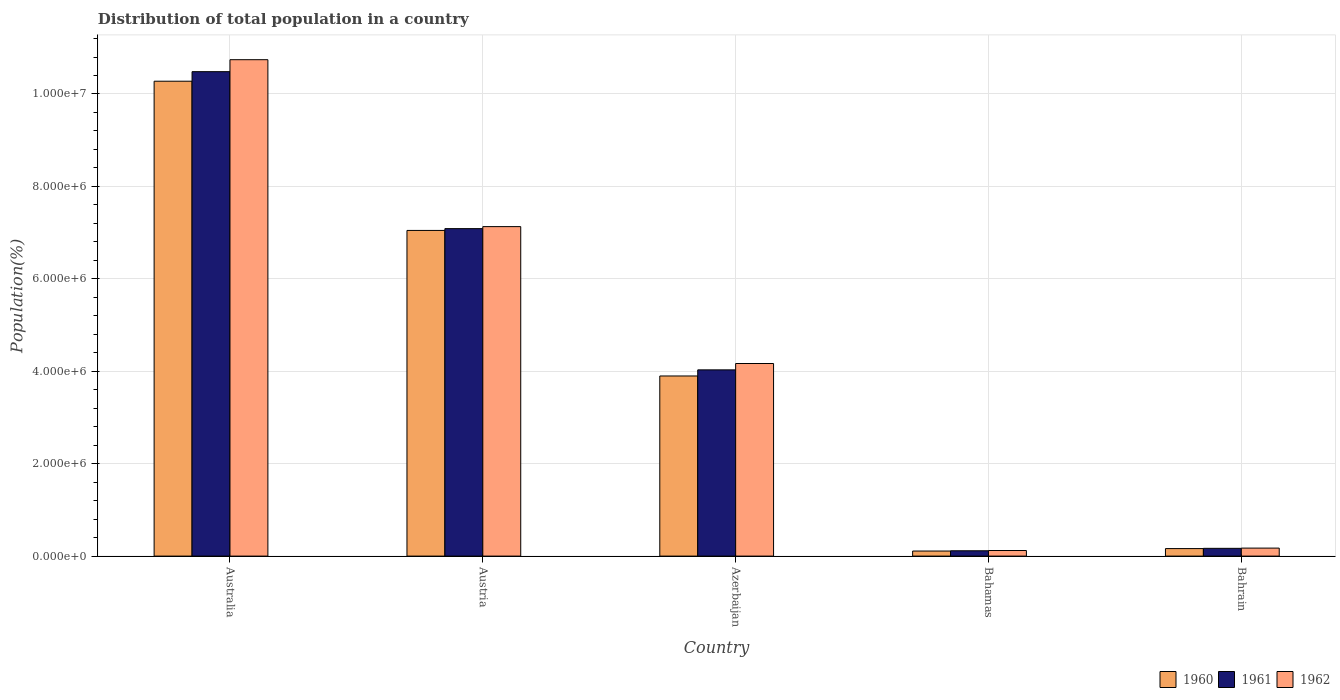How many groups of bars are there?
Make the answer very short. 5. Are the number of bars per tick equal to the number of legend labels?
Offer a terse response. Yes. How many bars are there on the 5th tick from the left?
Make the answer very short. 3. How many bars are there on the 4th tick from the right?
Offer a very short reply. 3. What is the label of the 3rd group of bars from the left?
Offer a very short reply. Azerbaijan. What is the population of in 1961 in Austria?
Your response must be concise. 7.09e+06. Across all countries, what is the maximum population of in 1962?
Your answer should be very brief. 1.07e+07. Across all countries, what is the minimum population of in 1960?
Give a very brief answer. 1.10e+05. In which country was the population of in 1960 maximum?
Give a very brief answer. Australia. In which country was the population of in 1960 minimum?
Offer a terse response. Bahamas. What is the total population of in 1962 in the graph?
Your answer should be very brief. 2.23e+07. What is the difference between the population of in 1961 in Bahamas and that in Bahrain?
Keep it short and to the point. -5.28e+04. What is the difference between the population of in 1960 in Bahrain and the population of in 1962 in Azerbaijan?
Your answer should be compact. -4.01e+06. What is the average population of in 1962 per country?
Ensure brevity in your answer.  4.47e+06. What is the difference between the population of of/in 1961 and population of of/in 1962 in Bahamas?
Your answer should be very brief. -5975. What is the ratio of the population of in 1961 in Australia to that in Azerbaijan?
Give a very brief answer. 2.6. Is the difference between the population of in 1961 in Azerbaijan and Bahrain greater than the difference between the population of in 1962 in Azerbaijan and Bahrain?
Give a very brief answer. No. What is the difference between the highest and the second highest population of in 1962?
Your response must be concise. 3.61e+06. What is the difference between the highest and the lowest population of in 1960?
Ensure brevity in your answer.  1.02e+07. Is the sum of the population of in 1960 in Austria and Azerbaijan greater than the maximum population of in 1961 across all countries?
Give a very brief answer. Yes. What does the 1st bar from the right in Bahrain represents?
Your answer should be very brief. 1962. Is it the case that in every country, the sum of the population of in 1961 and population of in 1960 is greater than the population of in 1962?
Give a very brief answer. Yes. Are all the bars in the graph horizontal?
Make the answer very short. No. How many countries are there in the graph?
Offer a terse response. 5. What is the difference between two consecutive major ticks on the Y-axis?
Offer a very short reply. 2.00e+06. Are the values on the major ticks of Y-axis written in scientific E-notation?
Provide a short and direct response. Yes. Does the graph contain any zero values?
Ensure brevity in your answer.  No. What is the title of the graph?
Provide a short and direct response. Distribution of total population in a country. What is the label or title of the X-axis?
Keep it short and to the point. Country. What is the label or title of the Y-axis?
Offer a terse response. Population(%). What is the Population(%) of 1960 in Australia?
Keep it short and to the point. 1.03e+07. What is the Population(%) of 1961 in Australia?
Make the answer very short. 1.05e+07. What is the Population(%) of 1962 in Australia?
Keep it short and to the point. 1.07e+07. What is the Population(%) in 1960 in Austria?
Your answer should be compact. 7.05e+06. What is the Population(%) of 1961 in Austria?
Provide a short and direct response. 7.09e+06. What is the Population(%) of 1962 in Austria?
Provide a short and direct response. 7.13e+06. What is the Population(%) in 1960 in Azerbaijan?
Your answer should be very brief. 3.90e+06. What is the Population(%) in 1961 in Azerbaijan?
Provide a short and direct response. 4.03e+06. What is the Population(%) in 1962 in Azerbaijan?
Give a very brief answer. 4.17e+06. What is the Population(%) of 1960 in Bahamas?
Give a very brief answer. 1.10e+05. What is the Population(%) of 1961 in Bahamas?
Ensure brevity in your answer.  1.15e+05. What is the Population(%) in 1962 in Bahamas?
Give a very brief answer. 1.21e+05. What is the Population(%) of 1960 in Bahrain?
Give a very brief answer. 1.63e+05. What is the Population(%) of 1961 in Bahrain?
Offer a terse response. 1.68e+05. What is the Population(%) in 1962 in Bahrain?
Give a very brief answer. 1.73e+05. Across all countries, what is the maximum Population(%) in 1960?
Provide a succinct answer. 1.03e+07. Across all countries, what is the maximum Population(%) in 1961?
Ensure brevity in your answer.  1.05e+07. Across all countries, what is the maximum Population(%) of 1962?
Your answer should be very brief. 1.07e+07. Across all countries, what is the minimum Population(%) of 1960?
Provide a succinct answer. 1.10e+05. Across all countries, what is the minimum Population(%) of 1961?
Ensure brevity in your answer.  1.15e+05. Across all countries, what is the minimum Population(%) of 1962?
Ensure brevity in your answer.  1.21e+05. What is the total Population(%) in 1960 in the graph?
Give a very brief answer. 2.15e+07. What is the total Population(%) in 1961 in the graph?
Give a very brief answer. 2.19e+07. What is the total Population(%) in 1962 in the graph?
Make the answer very short. 2.23e+07. What is the difference between the Population(%) of 1960 in Australia and that in Austria?
Provide a succinct answer. 3.23e+06. What is the difference between the Population(%) in 1961 in Australia and that in Austria?
Make the answer very short. 3.40e+06. What is the difference between the Population(%) of 1962 in Australia and that in Austria?
Provide a short and direct response. 3.61e+06. What is the difference between the Population(%) in 1960 in Australia and that in Azerbaijan?
Make the answer very short. 6.38e+06. What is the difference between the Population(%) of 1961 in Australia and that in Azerbaijan?
Offer a very short reply. 6.45e+06. What is the difference between the Population(%) in 1962 in Australia and that in Azerbaijan?
Offer a very short reply. 6.57e+06. What is the difference between the Population(%) in 1960 in Australia and that in Bahamas?
Provide a succinct answer. 1.02e+07. What is the difference between the Population(%) in 1961 in Australia and that in Bahamas?
Your response must be concise. 1.04e+07. What is the difference between the Population(%) in 1962 in Australia and that in Bahamas?
Offer a very short reply. 1.06e+07. What is the difference between the Population(%) in 1960 in Australia and that in Bahrain?
Your answer should be very brief. 1.01e+07. What is the difference between the Population(%) of 1961 in Australia and that in Bahrain?
Ensure brevity in your answer.  1.03e+07. What is the difference between the Population(%) of 1962 in Australia and that in Bahrain?
Ensure brevity in your answer.  1.06e+07. What is the difference between the Population(%) in 1960 in Austria and that in Azerbaijan?
Ensure brevity in your answer.  3.15e+06. What is the difference between the Population(%) in 1961 in Austria and that in Azerbaijan?
Offer a terse response. 3.06e+06. What is the difference between the Population(%) of 1962 in Austria and that in Azerbaijan?
Ensure brevity in your answer.  2.96e+06. What is the difference between the Population(%) in 1960 in Austria and that in Bahamas?
Provide a short and direct response. 6.94e+06. What is the difference between the Population(%) of 1961 in Austria and that in Bahamas?
Ensure brevity in your answer.  6.97e+06. What is the difference between the Population(%) of 1962 in Austria and that in Bahamas?
Provide a succinct answer. 7.01e+06. What is the difference between the Population(%) of 1960 in Austria and that in Bahrain?
Provide a short and direct response. 6.89e+06. What is the difference between the Population(%) of 1961 in Austria and that in Bahrain?
Your answer should be very brief. 6.92e+06. What is the difference between the Population(%) in 1962 in Austria and that in Bahrain?
Ensure brevity in your answer.  6.96e+06. What is the difference between the Population(%) of 1960 in Azerbaijan and that in Bahamas?
Your response must be concise. 3.79e+06. What is the difference between the Population(%) in 1961 in Azerbaijan and that in Bahamas?
Your answer should be very brief. 3.92e+06. What is the difference between the Population(%) of 1962 in Azerbaijan and that in Bahamas?
Provide a succinct answer. 4.05e+06. What is the difference between the Population(%) in 1960 in Azerbaijan and that in Bahrain?
Provide a short and direct response. 3.74e+06. What is the difference between the Population(%) in 1961 in Azerbaijan and that in Bahrain?
Your response must be concise. 3.86e+06. What is the difference between the Population(%) in 1962 in Azerbaijan and that in Bahrain?
Your answer should be compact. 3.99e+06. What is the difference between the Population(%) in 1960 in Bahamas and that in Bahrain?
Provide a succinct answer. -5.30e+04. What is the difference between the Population(%) of 1961 in Bahamas and that in Bahrain?
Keep it short and to the point. -5.28e+04. What is the difference between the Population(%) of 1962 in Bahamas and that in Bahrain?
Ensure brevity in your answer.  -5.20e+04. What is the difference between the Population(%) in 1960 in Australia and the Population(%) in 1961 in Austria?
Ensure brevity in your answer.  3.19e+06. What is the difference between the Population(%) in 1960 in Australia and the Population(%) in 1962 in Austria?
Provide a succinct answer. 3.15e+06. What is the difference between the Population(%) of 1961 in Australia and the Population(%) of 1962 in Austria?
Your answer should be compact. 3.35e+06. What is the difference between the Population(%) in 1960 in Australia and the Population(%) in 1961 in Azerbaijan?
Offer a very short reply. 6.25e+06. What is the difference between the Population(%) in 1960 in Australia and the Population(%) in 1962 in Azerbaijan?
Offer a terse response. 6.11e+06. What is the difference between the Population(%) in 1961 in Australia and the Population(%) in 1962 in Azerbaijan?
Offer a very short reply. 6.32e+06. What is the difference between the Population(%) in 1960 in Australia and the Population(%) in 1961 in Bahamas?
Your response must be concise. 1.02e+07. What is the difference between the Population(%) in 1960 in Australia and the Population(%) in 1962 in Bahamas?
Provide a short and direct response. 1.02e+07. What is the difference between the Population(%) of 1961 in Australia and the Population(%) of 1962 in Bahamas?
Ensure brevity in your answer.  1.04e+07. What is the difference between the Population(%) of 1960 in Australia and the Population(%) of 1961 in Bahrain?
Give a very brief answer. 1.01e+07. What is the difference between the Population(%) of 1960 in Australia and the Population(%) of 1962 in Bahrain?
Make the answer very short. 1.01e+07. What is the difference between the Population(%) in 1961 in Australia and the Population(%) in 1962 in Bahrain?
Offer a very short reply. 1.03e+07. What is the difference between the Population(%) of 1960 in Austria and the Population(%) of 1961 in Azerbaijan?
Make the answer very short. 3.02e+06. What is the difference between the Population(%) of 1960 in Austria and the Population(%) of 1962 in Azerbaijan?
Make the answer very short. 2.88e+06. What is the difference between the Population(%) of 1961 in Austria and the Population(%) of 1962 in Azerbaijan?
Offer a terse response. 2.92e+06. What is the difference between the Population(%) in 1960 in Austria and the Population(%) in 1961 in Bahamas?
Make the answer very short. 6.93e+06. What is the difference between the Population(%) in 1960 in Austria and the Population(%) in 1962 in Bahamas?
Your answer should be very brief. 6.93e+06. What is the difference between the Population(%) in 1961 in Austria and the Population(%) in 1962 in Bahamas?
Provide a succinct answer. 6.97e+06. What is the difference between the Population(%) of 1960 in Austria and the Population(%) of 1961 in Bahrain?
Provide a succinct answer. 6.88e+06. What is the difference between the Population(%) in 1960 in Austria and the Population(%) in 1962 in Bahrain?
Your answer should be very brief. 6.87e+06. What is the difference between the Population(%) of 1961 in Austria and the Population(%) of 1962 in Bahrain?
Keep it short and to the point. 6.91e+06. What is the difference between the Population(%) of 1960 in Azerbaijan and the Population(%) of 1961 in Bahamas?
Ensure brevity in your answer.  3.78e+06. What is the difference between the Population(%) in 1960 in Azerbaijan and the Population(%) in 1962 in Bahamas?
Your answer should be very brief. 3.78e+06. What is the difference between the Population(%) in 1961 in Azerbaijan and the Population(%) in 1962 in Bahamas?
Offer a very short reply. 3.91e+06. What is the difference between the Population(%) in 1960 in Azerbaijan and the Population(%) in 1961 in Bahrain?
Your answer should be compact. 3.73e+06. What is the difference between the Population(%) of 1960 in Azerbaijan and the Population(%) of 1962 in Bahrain?
Ensure brevity in your answer.  3.72e+06. What is the difference between the Population(%) in 1961 in Azerbaijan and the Population(%) in 1962 in Bahrain?
Your answer should be compact. 3.86e+06. What is the difference between the Population(%) of 1960 in Bahamas and the Population(%) of 1961 in Bahrain?
Provide a short and direct response. -5.84e+04. What is the difference between the Population(%) in 1960 in Bahamas and the Population(%) in 1962 in Bahrain?
Ensure brevity in your answer.  -6.36e+04. What is the difference between the Population(%) in 1961 in Bahamas and the Population(%) in 1962 in Bahrain?
Ensure brevity in your answer.  -5.80e+04. What is the average Population(%) in 1960 per country?
Your answer should be compact. 4.30e+06. What is the average Population(%) in 1961 per country?
Offer a very short reply. 4.38e+06. What is the average Population(%) in 1962 per country?
Give a very brief answer. 4.47e+06. What is the difference between the Population(%) in 1960 and Population(%) in 1961 in Australia?
Give a very brief answer. -2.07e+05. What is the difference between the Population(%) in 1960 and Population(%) in 1962 in Australia?
Offer a terse response. -4.66e+05. What is the difference between the Population(%) in 1961 and Population(%) in 1962 in Australia?
Make the answer very short. -2.59e+05. What is the difference between the Population(%) in 1960 and Population(%) in 1961 in Austria?
Your response must be concise. -3.88e+04. What is the difference between the Population(%) in 1960 and Population(%) in 1962 in Austria?
Provide a short and direct response. -8.23e+04. What is the difference between the Population(%) of 1961 and Population(%) of 1962 in Austria?
Your answer should be very brief. -4.36e+04. What is the difference between the Population(%) in 1960 and Population(%) in 1961 in Azerbaijan?
Give a very brief answer. -1.32e+05. What is the difference between the Population(%) of 1960 and Population(%) of 1962 in Azerbaijan?
Ensure brevity in your answer.  -2.70e+05. What is the difference between the Population(%) of 1961 and Population(%) of 1962 in Azerbaijan?
Your response must be concise. -1.37e+05. What is the difference between the Population(%) of 1960 and Population(%) of 1961 in Bahamas?
Give a very brief answer. -5582. What is the difference between the Population(%) of 1960 and Population(%) of 1962 in Bahamas?
Make the answer very short. -1.16e+04. What is the difference between the Population(%) of 1961 and Population(%) of 1962 in Bahamas?
Your answer should be compact. -5975. What is the difference between the Population(%) in 1960 and Population(%) in 1961 in Bahrain?
Offer a very short reply. -5423. What is the difference between the Population(%) in 1960 and Population(%) in 1962 in Bahrain?
Your answer should be compact. -1.06e+04. What is the difference between the Population(%) in 1961 and Population(%) in 1962 in Bahrain?
Provide a short and direct response. -5183. What is the ratio of the Population(%) in 1960 in Australia to that in Austria?
Offer a very short reply. 1.46. What is the ratio of the Population(%) in 1961 in Australia to that in Austria?
Your answer should be very brief. 1.48. What is the ratio of the Population(%) in 1962 in Australia to that in Austria?
Offer a very short reply. 1.51. What is the ratio of the Population(%) in 1960 in Australia to that in Azerbaijan?
Offer a very short reply. 2.64. What is the ratio of the Population(%) of 1961 in Australia to that in Azerbaijan?
Your response must be concise. 2.6. What is the ratio of the Population(%) of 1962 in Australia to that in Azerbaijan?
Provide a succinct answer. 2.58. What is the ratio of the Population(%) of 1960 in Australia to that in Bahamas?
Offer a very short reply. 93.83. What is the ratio of the Population(%) of 1961 in Australia to that in Bahamas?
Your answer should be very brief. 91.07. What is the ratio of the Population(%) of 1962 in Australia to that in Bahamas?
Ensure brevity in your answer.  88.72. What is the ratio of the Population(%) in 1960 in Australia to that in Bahrain?
Provide a short and direct response. 63.24. What is the ratio of the Population(%) of 1961 in Australia to that in Bahrain?
Give a very brief answer. 62.43. What is the ratio of the Population(%) in 1962 in Australia to that in Bahrain?
Keep it short and to the point. 62.05. What is the ratio of the Population(%) in 1960 in Austria to that in Azerbaijan?
Your response must be concise. 1.81. What is the ratio of the Population(%) in 1961 in Austria to that in Azerbaijan?
Ensure brevity in your answer.  1.76. What is the ratio of the Population(%) of 1962 in Austria to that in Azerbaijan?
Make the answer very short. 1.71. What is the ratio of the Population(%) of 1960 in Austria to that in Bahamas?
Your response must be concise. 64.35. What is the ratio of the Population(%) in 1961 in Austria to that in Bahamas?
Give a very brief answer. 61.56. What is the ratio of the Population(%) of 1962 in Austria to that in Bahamas?
Your response must be concise. 58.88. What is the ratio of the Population(%) of 1960 in Austria to that in Bahrain?
Your answer should be compact. 43.37. What is the ratio of the Population(%) of 1961 in Austria to that in Bahrain?
Ensure brevity in your answer.  42.2. What is the ratio of the Population(%) of 1962 in Austria to that in Bahrain?
Make the answer very short. 41.19. What is the ratio of the Population(%) in 1960 in Azerbaijan to that in Bahamas?
Provide a succinct answer. 35.59. What is the ratio of the Population(%) in 1961 in Azerbaijan to that in Bahamas?
Give a very brief answer. 35.01. What is the ratio of the Population(%) in 1962 in Azerbaijan to that in Bahamas?
Your response must be concise. 34.42. What is the ratio of the Population(%) in 1960 in Azerbaijan to that in Bahrain?
Offer a very short reply. 23.99. What is the ratio of the Population(%) in 1961 in Azerbaijan to that in Bahrain?
Keep it short and to the point. 24. What is the ratio of the Population(%) in 1962 in Azerbaijan to that in Bahrain?
Offer a terse response. 24.07. What is the ratio of the Population(%) of 1960 in Bahamas to that in Bahrain?
Ensure brevity in your answer.  0.67. What is the ratio of the Population(%) in 1961 in Bahamas to that in Bahrain?
Your answer should be compact. 0.69. What is the ratio of the Population(%) of 1962 in Bahamas to that in Bahrain?
Give a very brief answer. 0.7. What is the difference between the highest and the second highest Population(%) of 1960?
Ensure brevity in your answer.  3.23e+06. What is the difference between the highest and the second highest Population(%) in 1961?
Ensure brevity in your answer.  3.40e+06. What is the difference between the highest and the second highest Population(%) of 1962?
Your response must be concise. 3.61e+06. What is the difference between the highest and the lowest Population(%) in 1960?
Keep it short and to the point. 1.02e+07. What is the difference between the highest and the lowest Population(%) in 1961?
Offer a very short reply. 1.04e+07. What is the difference between the highest and the lowest Population(%) of 1962?
Offer a terse response. 1.06e+07. 